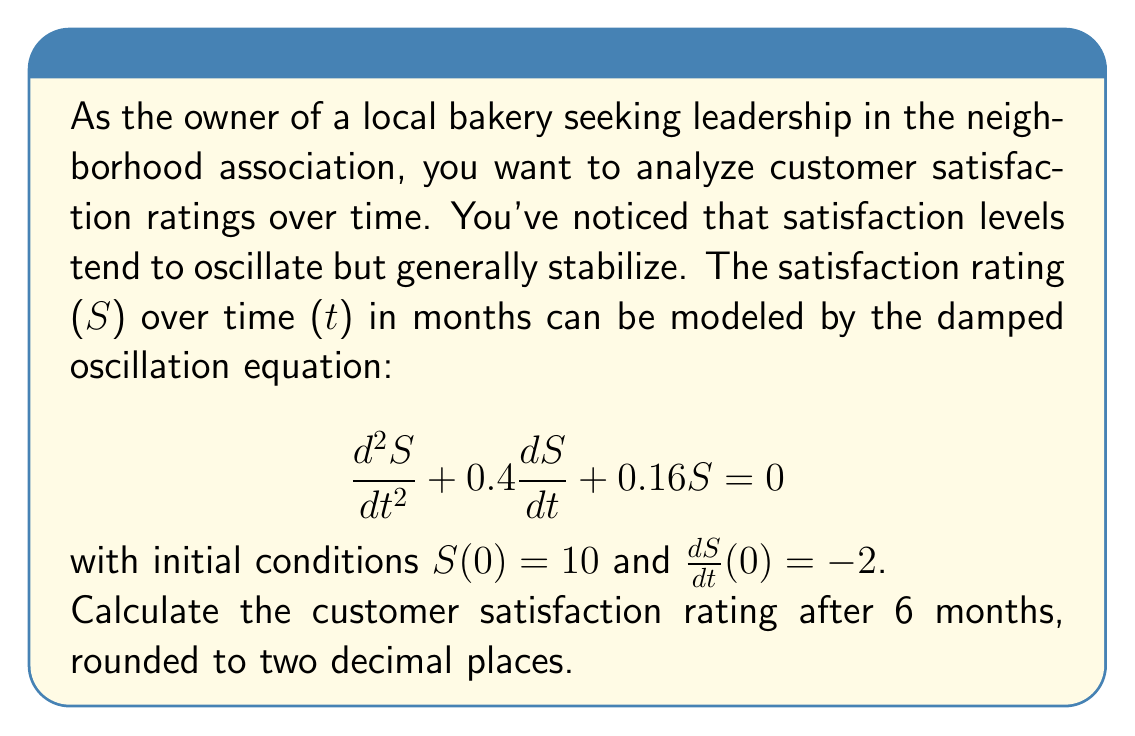Teach me how to tackle this problem. To solve this problem, we'll follow these steps:

1) The general solution for a damped oscillation equation of the form $\frac{d^2S}{dt^2} + 2\zeta\omega_n\frac{dS}{dt} + \omega_n^2S = 0$ is:

   $S(t) = e^{-\zeta\omega_n t}(A\cos(\omega_d t) + B\sin(\omega_d t))$

   where $\omega_d = \omega_n\sqrt{1-\zeta^2}$

2) From our equation, we can identify:
   $2\zeta\omega_n = 0.4$ and $\omega_n^2 = 0.16$

3) Solving these:
   $\omega_n = \sqrt{0.16} = 0.4$
   $\zeta = 0.4 / (2 * 0.4) = 0.5$

4) Calculate $\omega_d$:
   $\omega_d = 0.4\sqrt{1-0.5^2} = 0.4 * \sqrt{0.75} \approx 0.3464$

5) Our solution now looks like:
   $S(t) = e^{-0.2t}(A\cos(0.3464t) + B\sin(0.3464t))$

6) Use the initial conditions to find A and B:
   $S(0) = 10$, so $A = 10$
   $\frac{dS}{dt}(0) = -2$, so $-0.2A + 0.3464B = -2$
   Solving this: $B \approx 1.7321$

7) Our final solution is:
   $S(t) = e^{-0.2t}(10\cos(0.3464t) + 1.7321\sin(0.3464t))$

8) Plug in t = 6:
   $S(6) = e^{-0.2*6}(10\cos(0.3464*6) + 1.7321\sin(0.3464*6))$
   $\approx 0.3012 * (10 * (-0.7660) + 1.7321 * 0.6428)$
   $\approx 0.3012 * (-7.6600 + 1.1134)$
   $\approx 0.3012 * (-6.5466)$
   $\approx -1.97$
Answer: -1.97 